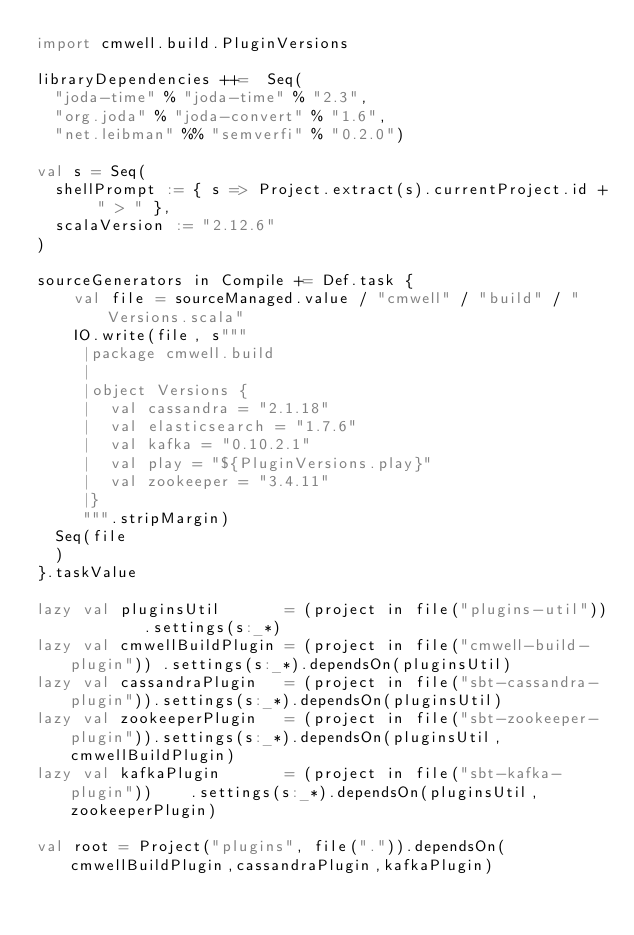Convert code to text. <code><loc_0><loc_0><loc_500><loc_500><_Scala_>import cmwell.build.PluginVersions

libraryDependencies ++=  Seq(
  "joda-time" % "joda-time" % "2.3",
  "org.joda" % "joda-convert" % "1.6",
  "net.leibman" %% "semverfi" % "0.2.0")

val s = Seq(
  shellPrompt := { s => Project.extract(s).currentProject.id + " > " },
  scalaVersion := "2.12.6"
)

sourceGenerators in Compile += Def.task {
    val file = sourceManaged.value / "cmwell" / "build" / "Versions.scala"
    IO.write(file, s"""
     |package cmwell.build
     |
     |object Versions {
     |  val cassandra = "2.1.18"
     |  val elasticsearch = "1.7.6"
     |  val kafka = "0.10.2.1"
     |  val play = "${PluginVersions.play}"
     |  val zookeeper = "3.4.11"
     |}
     """.stripMargin)
  Seq(file
  )
}.taskValue

lazy val pluginsUtil       = (project in file("plugins-util"))        .settings(s:_*)
lazy val cmwellBuildPlugin = (project in file("cmwell-build-plugin")) .settings(s:_*).dependsOn(pluginsUtil)
lazy val cassandraPlugin   = (project in file("sbt-cassandra-plugin")).settings(s:_*).dependsOn(pluginsUtil)
lazy val zookeeperPlugin   = (project in file("sbt-zookeeper-plugin")).settings(s:_*).dependsOn(pluginsUtil,cmwellBuildPlugin)
lazy val kafkaPlugin       = (project in file("sbt-kafka-plugin"))    .settings(s:_*).dependsOn(pluginsUtil,zookeeperPlugin)

val root = Project("plugins", file(".")).dependsOn(cmwellBuildPlugin,cassandraPlugin,kafkaPlugin)</code> 